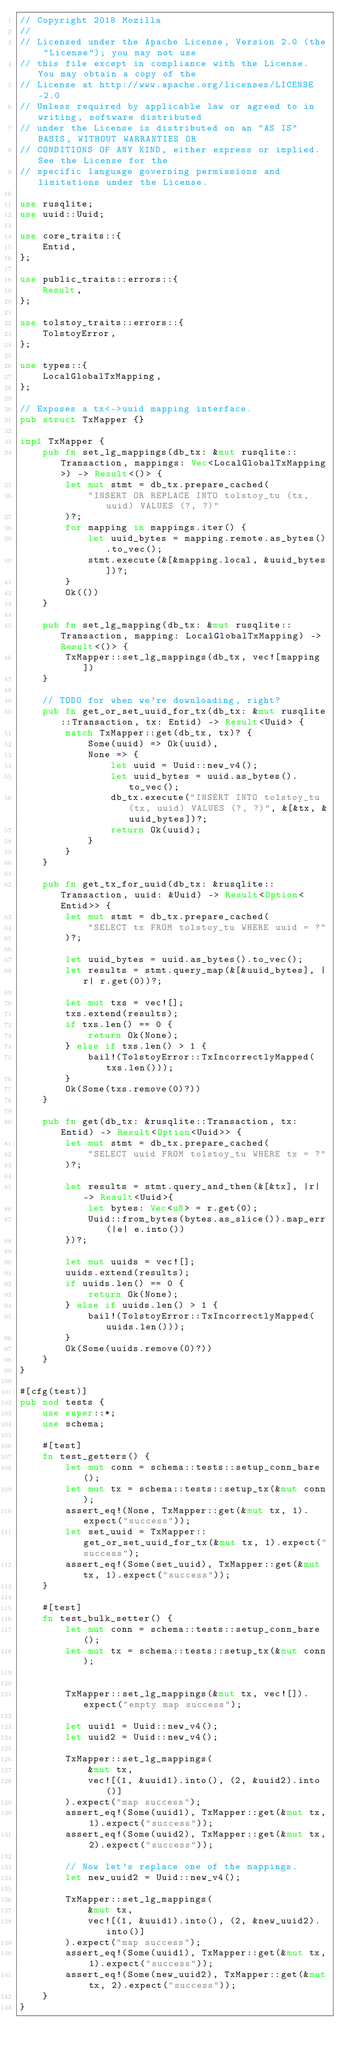Convert code to text. <code><loc_0><loc_0><loc_500><loc_500><_Rust_>// Copyright 2018 Mozilla
//
// Licensed under the Apache License, Version 2.0 (the "License"); you may not use
// this file except in compliance with the License. You may obtain a copy of the
// License at http://www.apache.org/licenses/LICENSE-2.0
// Unless required by applicable law or agreed to in writing, software distributed
// under the License is distributed on an "AS IS" BASIS, WITHOUT WARRANTIES OR
// CONDITIONS OF ANY KIND, either express or implied. See the License for the
// specific language governing permissions and limitations under the License.

use rusqlite;
use uuid::Uuid;

use core_traits::{
    Entid,
};

use public_traits::errors::{
    Result,
};

use tolstoy_traits::errors::{
    TolstoyError,
};

use types::{
    LocalGlobalTxMapping,
};

// Exposes a tx<->uuid mapping interface.
pub struct TxMapper {}

impl TxMapper {
    pub fn set_lg_mappings(db_tx: &mut rusqlite::Transaction, mappings: Vec<LocalGlobalTxMapping>) -> Result<()> {
        let mut stmt = db_tx.prepare_cached(
            "INSERT OR REPLACE INTO tolstoy_tu (tx, uuid) VALUES (?, ?)"
        )?;
        for mapping in mappings.iter() {
            let uuid_bytes = mapping.remote.as_bytes().to_vec();
            stmt.execute(&[&mapping.local, &uuid_bytes])?;
        }
        Ok(())
    }

    pub fn set_lg_mapping(db_tx: &mut rusqlite::Transaction, mapping: LocalGlobalTxMapping) -> Result<()> {
        TxMapper::set_lg_mappings(db_tx, vec![mapping])
    }

    // TODO for when we're downloading, right?
    pub fn get_or_set_uuid_for_tx(db_tx: &mut rusqlite::Transaction, tx: Entid) -> Result<Uuid> {
        match TxMapper::get(db_tx, tx)? {
            Some(uuid) => Ok(uuid),
            None => {
                let uuid = Uuid::new_v4();
                let uuid_bytes = uuid.as_bytes().to_vec();
                db_tx.execute("INSERT INTO tolstoy_tu (tx, uuid) VALUES (?, ?)", &[&tx, &uuid_bytes])?;
                return Ok(uuid);
            }
        }
    }

    pub fn get_tx_for_uuid(db_tx: &rusqlite::Transaction, uuid: &Uuid) -> Result<Option<Entid>> {
        let mut stmt = db_tx.prepare_cached(
            "SELECT tx FROM tolstoy_tu WHERE uuid = ?"
        )?;

        let uuid_bytes = uuid.as_bytes().to_vec();
        let results = stmt.query_map(&[&uuid_bytes], |r| r.get(0))?;

        let mut txs = vec![];
        txs.extend(results);
        if txs.len() == 0 {
            return Ok(None);
        } else if txs.len() > 1 {
            bail!(TolstoyError::TxIncorrectlyMapped(txs.len()));
        }
        Ok(Some(txs.remove(0)?))
    }

    pub fn get(db_tx: &rusqlite::Transaction, tx: Entid) -> Result<Option<Uuid>> {
        let mut stmt = db_tx.prepare_cached(
            "SELECT uuid FROM tolstoy_tu WHERE tx = ?"
        )?;

        let results = stmt.query_and_then(&[&tx], |r| -> Result<Uuid>{
            let bytes: Vec<u8> = r.get(0);
            Uuid::from_bytes(bytes.as_slice()).map_err(|e| e.into())
        })?;

        let mut uuids = vec![];
        uuids.extend(results);
        if uuids.len() == 0 {
            return Ok(None);
        } else if uuids.len() > 1 {
            bail!(TolstoyError::TxIncorrectlyMapped(uuids.len()));
        }
        Ok(Some(uuids.remove(0)?))
    }
}

#[cfg(test)]
pub mod tests {
    use super::*;
    use schema;

    #[test]
    fn test_getters() {
        let mut conn = schema::tests::setup_conn_bare();
        let mut tx = schema::tests::setup_tx(&mut conn);
        assert_eq!(None, TxMapper::get(&mut tx, 1).expect("success"));
        let set_uuid = TxMapper::get_or_set_uuid_for_tx(&mut tx, 1).expect("success");
        assert_eq!(Some(set_uuid), TxMapper::get(&mut tx, 1).expect("success"));
    }

    #[test]
    fn test_bulk_setter() {
        let mut conn = schema::tests::setup_conn_bare();
        let mut tx = schema::tests::setup_tx(&mut conn);
        

        TxMapper::set_lg_mappings(&mut tx, vec![]).expect("empty map success");

        let uuid1 = Uuid::new_v4();
        let uuid2 = Uuid::new_v4();

        TxMapper::set_lg_mappings(
            &mut tx,
            vec![(1, &uuid1).into(), (2, &uuid2).into()]
        ).expect("map success");
        assert_eq!(Some(uuid1), TxMapper::get(&mut tx, 1).expect("success"));
        assert_eq!(Some(uuid2), TxMapper::get(&mut tx, 2).expect("success"));

        // Now let's replace one of the mappings.
        let new_uuid2 = Uuid::new_v4();

        TxMapper::set_lg_mappings(
            &mut tx,
            vec![(1, &uuid1).into(), (2, &new_uuid2).into()]
        ).expect("map success");
        assert_eq!(Some(uuid1), TxMapper::get(&mut tx, 1).expect("success"));
        assert_eq!(Some(new_uuid2), TxMapper::get(&mut tx, 2).expect("success"));
    }
}
</code> 